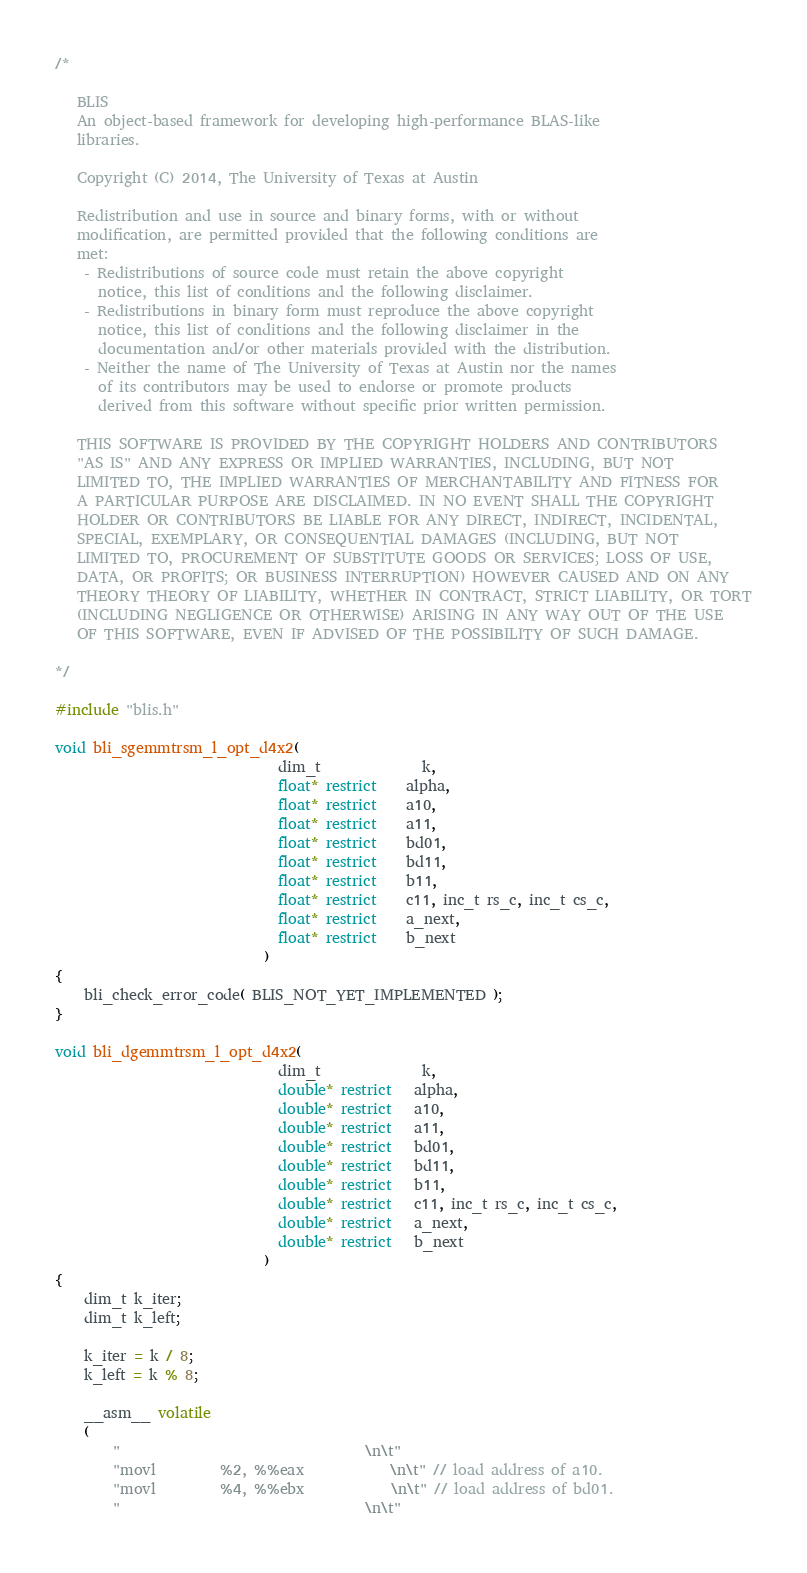Convert code to text. <code><loc_0><loc_0><loc_500><loc_500><_C_>/*

   BLIS    
   An object-based framework for developing high-performance BLAS-like
   libraries.

   Copyright (C) 2014, The University of Texas at Austin

   Redistribution and use in source and binary forms, with or without
   modification, are permitted provided that the following conditions are
   met:
    - Redistributions of source code must retain the above copyright
      notice, this list of conditions and the following disclaimer.
    - Redistributions in binary form must reproduce the above copyright
      notice, this list of conditions and the following disclaimer in the
      documentation and/or other materials provided with the distribution.
    - Neither the name of The University of Texas at Austin nor the names
      of its contributors may be used to endorse or promote products
      derived from this software without specific prior written permission.

   THIS SOFTWARE IS PROVIDED BY THE COPYRIGHT HOLDERS AND CONTRIBUTORS
   "AS IS" AND ANY EXPRESS OR IMPLIED WARRANTIES, INCLUDING, BUT NOT
   LIMITED TO, THE IMPLIED WARRANTIES OF MERCHANTABILITY AND FITNESS FOR
   A PARTICULAR PURPOSE ARE DISCLAIMED. IN NO EVENT SHALL THE COPYRIGHT
   HOLDER OR CONTRIBUTORS BE LIABLE FOR ANY DIRECT, INDIRECT, INCIDENTAL,
   SPECIAL, EXEMPLARY, OR CONSEQUENTIAL DAMAGES (INCLUDING, BUT NOT
   LIMITED TO, PROCUREMENT OF SUBSTITUTE GOODS OR SERVICES; LOSS OF USE,
   DATA, OR PROFITS; OR BUSINESS INTERRUPTION) HOWEVER CAUSED AND ON ANY
   THEORY THEORY OF LIABILITY, WHETHER IN CONTRACT, STRICT LIABILITY, OR TORT
   (INCLUDING NEGLIGENCE OR OTHERWISE) ARISING IN ANY WAY OUT OF THE USE
   OF THIS SOFTWARE, EVEN IF ADVISED OF THE POSSIBILITY OF SUCH DAMAGE.

*/

#include "blis.h"

void bli_sgemmtrsm_l_opt_d4x2(
                               dim_t              k,
                               float* restrict    alpha,
                               float* restrict    a10,
                               float* restrict    a11,
                               float* restrict    bd01,
                               float* restrict    bd11,
                               float* restrict    b11,
                               float* restrict    c11, inc_t rs_c, inc_t cs_c,
                               float* restrict    a_next,
                               float* restrict    b_next
                             )
{
	bli_check_error_code( BLIS_NOT_YET_IMPLEMENTED );
}

void bli_dgemmtrsm_l_opt_d4x2(
                               dim_t              k,
                               double* restrict   alpha,
                               double* restrict   a10,
                               double* restrict   a11,
                               double* restrict   bd01,
                               double* restrict   bd11,
                               double* restrict   b11,
                               double* restrict   c11, inc_t rs_c, inc_t cs_c,
                               double* restrict   a_next,
                               double* restrict   b_next
                             )
{
	dim_t k_iter;
	dim_t k_left;

	k_iter = k / 8;
	k_left = k % 8;

	__asm__ volatile
	(
		"                                  \n\t"
		"movl         %2, %%eax            \n\t" // load address of a10.
		"movl         %4, %%ebx            \n\t" // load address of bd01.
		"                                  \n\t"</code> 